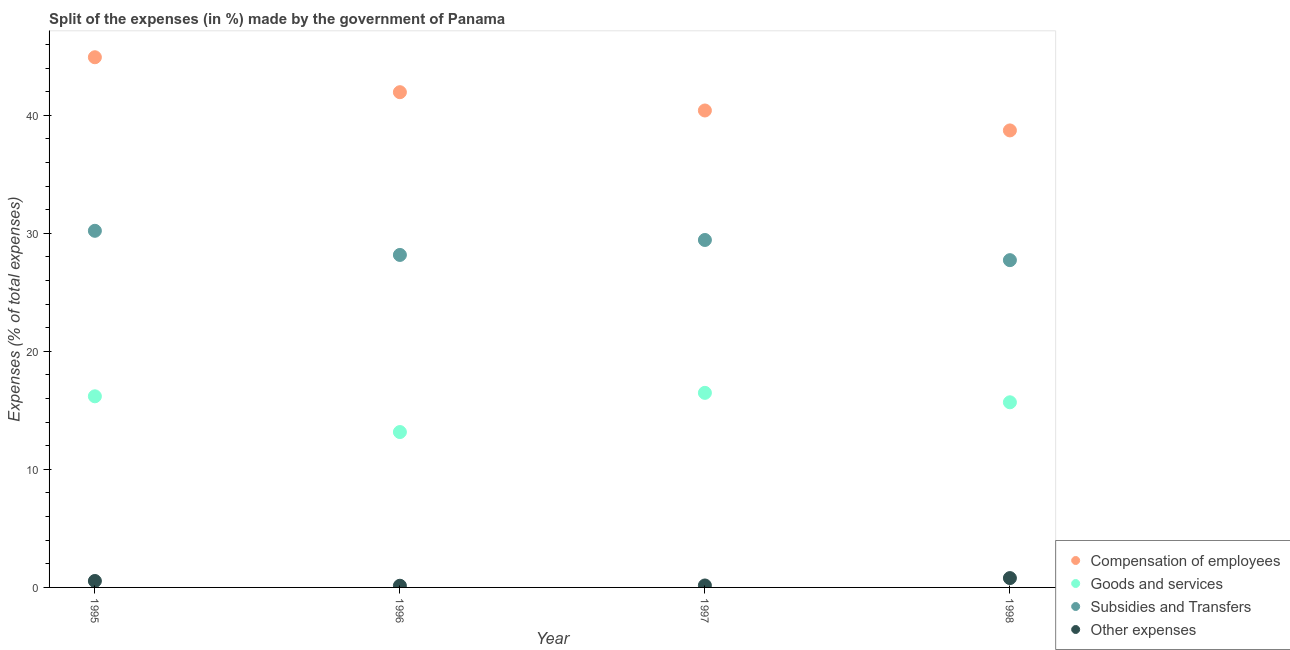Is the number of dotlines equal to the number of legend labels?
Your answer should be compact. Yes. What is the percentage of amount spent on compensation of employees in 1995?
Offer a very short reply. 44.91. Across all years, what is the maximum percentage of amount spent on subsidies?
Your response must be concise. 30.21. Across all years, what is the minimum percentage of amount spent on other expenses?
Provide a succinct answer. 0.14. In which year was the percentage of amount spent on subsidies minimum?
Provide a short and direct response. 1998. What is the total percentage of amount spent on goods and services in the graph?
Your answer should be very brief. 61.52. What is the difference between the percentage of amount spent on subsidies in 1995 and that in 1997?
Your answer should be very brief. 0.78. What is the difference between the percentage of amount spent on other expenses in 1998 and the percentage of amount spent on goods and services in 1996?
Ensure brevity in your answer.  -12.37. What is the average percentage of amount spent on subsidies per year?
Make the answer very short. 28.88. In the year 1996, what is the difference between the percentage of amount spent on other expenses and percentage of amount spent on compensation of employees?
Your response must be concise. -41.81. What is the ratio of the percentage of amount spent on compensation of employees in 1995 to that in 1996?
Your response must be concise. 1.07. What is the difference between the highest and the second highest percentage of amount spent on goods and services?
Ensure brevity in your answer.  0.29. What is the difference between the highest and the lowest percentage of amount spent on other expenses?
Provide a succinct answer. 0.65. Is it the case that in every year, the sum of the percentage of amount spent on other expenses and percentage of amount spent on compensation of employees is greater than the sum of percentage of amount spent on subsidies and percentage of amount spent on goods and services?
Your response must be concise. Yes. Is the percentage of amount spent on other expenses strictly greater than the percentage of amount spent on goods and services over the years?
Provide a succinct answer. No. How many dotlines are there?
Offer a terse response. 4. What is the difference between two consecutive major ticks on the Y-axis?
Give a very brief answer. 10. Does the graph contain grids?
Your answer should be compact. No. Where does the legend appear in the graph?
Offer a terse response. Bottom right. How many legend labels are there?
Offer a very short reply. 4. What is the title of the graph?
Keep it short and to the point. Split of the expenses (in %) made by the government of Panama. What is the label or title of the X-axis?
Offer a terse response. Year. What is the label or title of the Y-axis?
Give a very brief answer. Expenses (% of total expenses). What is the Expenses (% of total expenses) in Compensation of employees in 1995?
Your answer should be very brief. 44.91. What is the Expenses (% of total expenses) of Goods and services in 1995?
Your answer should be compact. 16.19. What is the Expenses (% of total expenses) in Subsidies and Transfers in 1995?
Offer a very short reply. 30.21. What is the Expenses (% of total expenses) of Other expenses in 1995?
Make the answer very short. 0.55. What is the Expenses (% of total expenses) of Compensation of employees in 1996?
Offer a terse response. 41.95. What is the Expenses (% of total expenses) in Goods and services in 1996?
Keep it short and to the point. 13.16. What is the Expenses (% of total expenses) of Subsidies and Transfers in 1996?
Keep it short and to the point. 28.17. What is the Expenses (% of total expenses) of Other expenses in 1996?
Ensure brevity in your answer.  0.14. What is the Expenses (% of total expenses) in Compensation of employees in 1997?
Your answer should be very brief. 40.4. What is the Expenses (% of total expenses) in Goods and services in 1997?
Provide a succinct answer. 16.48. What is the Expenses (% of total expenses) in Subsidies and Transfers in 1997?
Provide a succinct answer. 29.43. What is the Expenses (% of total expenses) in Other expenses in 1997?
Provide a short and direct response. 0.17. What is the Expenses (% of total expenses) of Compensation of employees in 1998?
Provide a short and direct response. 38.71. What is the Expenses (% of total expenses) of Goods and services in 1998?
Keep it short and to the point. 15.68. What is the Expenses (% of total expenses) in Subsidies and Transfers in 1998?
Ensure brevity in your answer.  27.72. What is the Expenses (% of total expenses) of Other expenses in 1998?
Offer a terse response. 0.79. Across all years, what is the maximum Expenses (% of total expenses) of Compensation of employees?
Provide a succinct answer. 44.91. Across all years, what is the maximum Expenses (% of total expenses) in Goods and services?
Make the answer very short. 16.48. Across all years, what is the maximum Expenses (% of total expenses) in Subsidies and Transfers?
Your response must be concise. 30.21. Across all years, what is the maximum Expenses (% of total expenses) in Other expenses?
Keep it short and to the point. 0.79. Across all years, what is the minimum Expenses (% of total expenses) in Compensation of employees?
Your answer should be compact. 38.71. Across all years, what is the minimum Expenses (% of total expenses) in Goods and services?
Keep it short and to the point. 13.16. Across all years, what is the minimum Expenses (% of total expenses) of Subsidies and Transfers?
Give a very brief answer. 27.72. Across all years, what is the minimum Expenses (% of total expenses) of Other expenses?
Your answer should be very brief. 0.14. What is the total Expenses (% of total expenses) in Compensation of employees in the graph?
Make the answer very short. 165.98. What is the total Expenses (% of total expenses) of Goods and services in the graph?
Keep it short and to the point. 61.52. What is the total Expenses (% of total expenses) in Subsidies and Transfers in the graph?
Keep it short and to the point. 115.53. What is the total Expenses (% of total expenses) of Other expenses in the graph?
Give a very brief answer. 1.65. What is the difference between the Expenses (% of total expenses) in Compensation of employees in 1995 and that in 1996?
Ensure brevity in your answer.  2.96. What is the difference between the Expenses (% of total expenses) of Goods and services in 1995 and that in 1996?
Keep it short and to the point. 3.03. What is the difference between the Expenses (% of total expenses) of Subsidies and Transfers in 1995 and that in 1996?
Your response must be concise. 2.04. What is the difference between the Expenses (% of total expenses) of Other expenses in 1995 and that in 1996?
Your answer should be very brief. 0.4. What is the difference between the Expenses (% of total expenses) of Compensation of employees in 1995 and that in 1997?
Ensure brevity in your answer.  4.51. What is the difference between the Expenses (% of total expenses) of Goods and services in 1995 and that in 1997?
Your response must be concise. -0.29. What is the difference between the Expenses (% of total expenses) in Subsidies and Transfers in 1995 and that in 1997?
Give a very brief answer. 0.78. What is the difference between the Expenses (% of total expenses) in Other expenses in 1995 and that in 1997?
Provide a succinct answer. 0.38. What is the difference between the Expenses (% of total expenses) in Compensation of employees in 1995 and that in 1998?
Offer a terse response. 6.2. What is the difference between the Expenses (% of total expenses) in Goods and services in 1995 and that in 1998?
Your answer should be very brief. 0.51. What is the difference between the Expenses (% of total expenses) in Subsidies and Transfers in 1995 and that in 1998?
Offer a terse response. 2.49. What is the difference between the Expenses (% of total expenses) in Other expenses in 1995 and that in 1998?
Ensure brevity in your answer.  -0.25. What is the difference between the Expenses (% of total expenses) in Compensation of employees in 1996 and that in 1997?
Provide a succinct answer. 1.55. What is the difference between the Expenses (% of total expenses) of Goods and services in 1996 and that in 1997?
Keep it short and to the point. -3.32. What is the difference between the Expenses (% of total expenses) in Subsidies and Transfers in 1996 and that in 1997?
Provide a succinct answer. -1.27. What is the difference between the Expenses (% of total expenses) in Other expenses in 1996 and that in 1997?
Your response must be concise. -0.02. What is the difference between the Expenses (% of total expenses) of Compensation of employees in 1996 and that in 1998?
Provide a succinct answer. 3.24. What is the difference between the Expenses (% of total expenses) in Goods and services in 1996 and that in 1998?
Provide a short and direct response. -2.52. What is the difference between the Expenses (% of total expenses) in Subsidies and Transfers in 1996 and that in 1998?
Offer a terse response. 0.44. What is the difference between the Expenses (% of total expenses) of Other expenses in 1996 and that in 1998?
Provide a short and direct response. -0.65. What is the difference between the Expenses (% of total expenses) of Compensation of employees in 1997 and that in 1998?
Offer a terse response. 1.69. What is the difference between the Expenses (% of total expenses) in Goods and services in 1997 and that in 1998?
Your answer should be very brief. 0.8. What is the difference between the Expenses (% of total expenses) of Subsidies and Transfers in 1997 and that in 1998?
Your answer should be compact. 1.71. What is the difference between the Expenses (% of total expenses) of Other expenses in 1997 and that in 1998?
Make the answer very short. -0.63. What is the difference between the Expenses (% of total expenses) in Compensation of employees in 1995 and the Expenses (% of total expenses) in Goods and services in 1996?
Your answer should be very brief. 31.75. What is the difference between the Expenses (% of total expenses) of Compensation of employees in 1995 and the Expenses (% of total expenses) of Subsidies and Transfers in 1996?
Offer a very short reply. 16.75. What is the difference between the Expenses (% of total expenses) in Compensation of employees in 1995 and the Expenses (% of total expenses) in Other expenses in 1996?
Provide a short and direct response. 44.77. What is the difference between the Expenses (% of total expenses) in Goods and services in 1995 and the Expenses (% of total expenses) in Subsidies and Transfers in 1996?
Your response must be concise. -11.98. What is the difference between the Expenses (% of total expenses) in Goods and services in 1995 and the Expenses (% of total expenses) in Other expenses in 1996?
Offer a terse response. 16.05. What is the difference between the Expenses (% of total expenses) in Subsidies and Transfers in 1995 and the Expenses (% of total expenses) in Other expenses in 1996?
Provide a succinct answer. 30.07. What is the difference between the Expenses (% of total expenses) in Compensation of employees in 1995 and the Expenses (% of total expenses) in Goods and services in 1997?
Ensure brevity in your answer.  28.43. What is the difference between the Expenses (% of total expenses) in Compensation of employees in 1995 and the Expenses (% of total expenses) in Subsidies and Transfers in 1997?
Ensure brevity in your answer.  15.48. What is the difference between the Expenses (% of total expenses) of Compensation of employees in 1995 and the Expenses (% of total expenses) of Other expenses in 1997?
Offer a terse response. 44.75. What is the difference between the Expenses (% of total expenses) of Goods and services in 1995 and the Expenses (% of total expenses) of Subsidies and Transfers in 1997?
Your answer should be very brief. -13.24. What is the difference between the Expenses (% of total expenses) of Goods and services in 1995 and the Expenses (% of total expenses) of Other expenses in 1997?
Offer a very short reply. 16.02. What is the difference between the Expenses (% of total expenses) in Subsidies and Transfers in 1995 and the Expenses (% of total expenses) in Other expenses in 1997?
Give a very brief answer. 30.04. What is the difference between the Expenses (% of total expenses) of Compensation of employees in 1995 and the Expenses (% of total expenses) of Goods and services in 1998?
Your response must be concise. 29.23. What is the difference between the Expenses (% of total expenses) in Compensation of employees in 1995 and the Expenses (% of total expenses) in Subsidies and Transfers in 1998?
Your answer should be compact. 17.19. What is the difference between the Expenses (% of total expenses) in Compensation of employees in 1995 and the Expenses (% of total expenses) in Other expenses in 1998?
Make the answer very short. 44.12. What is the difference between the Expenses (% of total expenses) of Goods and services in 1995 and the Expenses (% of total expenses) of Subsidies and Transfers in 1998?
Keep it short and to the point. -11.53. What is the difference between the Expenses (% of total expenses) in Goods and services in 1995 and the Expenses (% of total expenses) in Other expenses in 1998?
Offer a very short reply. 15.4. What is the difference between the Expenses (% of total expenses) of Subsidies and Transfers in 1995 and the Expenses (% of total expenses) of Other expenses in 1998?
Your answer should be very brief. 29.42. What is the difference between the Expenses (% of total expenses) of Compensation of employees in 1996 and the Expenses (% of total expenses) of Goods and services in 1997?
Your answer should be compact. 25.47. What is the difference between the Expenses (% of total expenses) of Compensation of employees in 1996 and the Expenses (% of total expenses) of Subsidies and Transfers in 1997?
Your response must be concise. 12.52. What is the difference between the Expenses (% of total expenses) in Compensation of employees in 1996 and the Expenses (% of total expenses) in Other expenses in 1997?
Offer a very short reply. 41.79. What is the difference between the Expenses (% of total expenses) in Goods and services in 1996 and the Expenses (% of total expenses) in Subsidies and Transfers in 1997?
Your answer should be very brief. -16.27. What is the difference between the Expenses (% of total expenses) in Goods and services in 1996 and the Expenses (% of total expenses) in Other expenses in 1997?
Offer a very short reply. 13. What is the difference between the Expenses (% of total expenses) in Subsidies and Transfers in 1996 and the Expenses (% of total expenses) in Other expenses in 1997?
Offer a terse response. 28. What is the difference between the Expenses (% of total expenses) in Compensation of employees in 1996 and the Expenses (% of total expenses) in Goods and services in 1998?
Your response must be concise. 26.27. What is the difference between the Expenses (% of total expenses) in Compensation of employees in 1996 and the Expenses (% of total expenses) in Subsidies and Transfers in 1998?
Provide a short and direct response. 14.23. What is the difference between the Expenses (% of total expenses) of Compensation of employees in 1996 and the Expenses (% of total expenses) of Other expenses in 1998?
Keep it short and to the point. 41.16. What is the difference between the Expenses (% of total expenses) of Goods and services in 1996 and the Expenses (% of total expenses) of Subsidies and Transfers in 1998?
Make the answer very short. -14.56. What is the difference between the Expenses (% of total expenses) of Goods and services in 1996 and the Expenses (% of total expenses) of Other expenses in 1998?
Make the answer very short. 12.37. What is the difference between the Expenses (% of total expenses) of Subsidies and Transfers in 1996 and the Expenses (% of total expenses) of Other expenses in 1998?
Offer a very short reply. 27.37. What is the difference between the Expenses (% of total expenses) in Compensation of employees in 1997 and the Expenses (% of total expenses) in Goods and services in 1998?
Provide a short and direct response. 24.72. What is the difference between the Expenses (% of total expenses) of Compensation of employees in 1997 and the Expenses (% of total expenses) of Subsidies and Transfers in 1998?
Your response must be concise. 12.68. What is the difference between the Expenses (% of total expenses) in Compensation of employees in 1997 and the Expenses (% of total expenses) in Other expenses in 1998?
Give a very brief answer. 39.61. What is the difference between the Expenses (% of total expenses) in Goods and services in 1997 and the Expenses (% of total expenses) in Subsidies and Transfers in 1998?
Ensure brevity in your answer.  -11.24. What is the difference between the Expenses (% of total expenses) of Goods and services in 1997 and the Expenses (% of total expenses) of Other expenses in 1998?
Provide a short and direct response. 15.69. What is the difference between the Expenses (% of total expenses) of Subsidies and Transfers in 1997 and the Expenses (% of total expenses) of Other expenses in 1998?
Your response must be concise. 28.64. What is the average Expenses (% of total expenses) of Compensation of employees per year?
Provide a short and direct response. 41.5. What is the average Expenses (% of total expenses) of Goods and services per year?
Give a very brief answer. 15.38. What is the average Expenses (% of total expenses) in Subsidies and Transfers per year?
Offer a very short reply. 28.88. What is the average Expenses (% of total expenses) of Other expenses per year?
Your answer should be very brief. 0.41. In the year 1995, what is the difference between the Expenses (% of total expenses) of Compensation of employees and Expenses (% of total expenses) of Goods and services?
Your answer should be very brief. 28.72. In the year 1995, what is the difference between the Expenses (% of total expenses) of Compensation of employees and Expenses (% of total expenses) of Subsidies and Transfers?
Your answer should be very brief. 14.7. In the year 1995, what is the difference between the Expenses (% of total expenses) of Compensation of employees and Expenses (% of total expenses) of Other expenses?
Ensure brevity in your answer.  44.37. In the year 1995, what is the difference between the Expenses (% of total expenses) in Goods and services and Expenses (% of total expenses) in Subsidies and Transfers?
Ensure brevity in your answer.  -14.02. In the year 1995, what is the difference between the Expenses (% of total expenses) of Goods and services and Expenses (% of total expenses) of Other expenses?
Make the answer very short. 15.64. In the year 1995, what is the difference between the Expenses (% of total expenses) of Subsidies and Transfers and Expenses (% of total expenses) of Other expenses?
Make the answer very short. 29.66. In the year 1996, what is the difference between the Expenses (% of total expenses) in Compensation of employees and Expenses (% of total expenses) in Goods and services?
Keep it short and to the point. 28.79. In the year 1996, what is the difference between the Expenses (% of total expenses) in Compensation of employees and Expenses (% of total expenses) in Subsidies and Transfers?
Give a very brief answer. 13.79. In the year 1996, what is the difference between the Expenses (% of total expenses) of Compensation of employees and Expenses (% of total expenses) of Other expenses?
Your answer should be very brief. 41.81. In the year 1996, what is the difference between the Expenses (% of total expenses) of Goods and services and Expenses (% of total expenses) of Subsidies and Transfers?
Provide a short and direct response. -15. In the year 1996, what is the difference between the Expenses (% of total expenses) in Goods and services and Expenses (% of total expenses) in Other expenses?
Your answer should be very brief. 13.02. In the year 1996, what is the difference between the Expenses (% of total expenses) of Subsidies and Transfers and Expenses (% of total expenses) of Other expenses?
Your answer should be very brief. 28.02. In the year 1997, what is the difference between the Expenses (% of total expenses) of Compensation of employees and Expenses (% of total expenses) of Goods and services?
Provide a succinct answer. 23.92. In the year 1997, what is the difference between the Expenses (% of total expenses) in Compensation of employees and Expenses (% of total expenses) in Subsidies and Transfers?
Provide a succinct answer. 10.97. In the year 1997, what is the difference between the Expenses (% of total expenses) of Compensation of employees and Expenses (% of total expenses) of Other expenses?
Keep it short and to the point. 40.24. In the year 1997, what is the difference between the Expenses (% of total expenses) in Goods and services and Expenses (% of total expenses) in Subsidies and Transfers?
Offer a terse response. -12.95. In the year 1997, what is the difference between the Expenses (% of total expenses) of Goods and services and Expenses (% of total expenses) of Other expenses?
Your answer should be compact. 16.32. In the year 1997, what is the difference between the Expenses (% of total expenses) of Subsidies and Transfers and Expenses (% of total expenses) of Other expenses?
Offer a terse response. 29.27. In the year 1998, what is the difference between the Expenses (% of total expenses) of Compensation of employees and Expenses (% of total expenses) of Goods and services?
Your answer should be compact. 23.03. In the year 1998, what is the difference between the Expenses (% of total expenses) of Compensation of employees and Expenses (% of total expenses) of Subsidies and Transfers?
Offer a very short reply. 10.99. In the year 1998, what is the difference between the Expenses (% of total expenses) of Compensation of employees and Expenses (% of total expenses) of Other expenses?
Your response must be concise. 37.92. In the year 1998, what is the difference between the Expenses (% of total expenses) in Goods and services and Expenses (% of total expenses) in Subsidies and Transfers?
Give a very brief answer. -12.04. In the year 1998, what is the difference between the Expenses (% of total expenses) in Goods and services and Expenses (% of total expenses) in Other expenses?
Your answer should be very brief. 14.89. In the year 1998, what is the difference between the Expenses (% of total expenses) in Subsidies and Transfers and Expenses (% of total expenses) in Other expenses?
Keep it short and to the point. 26.93. What is the ratio of the Expenses (% of total expenses) in Compensation of employees in 1995 to that in 1996?
Offer a very short reply. 1.07. What is the ratio of the Expenses (% of total expenses) in Goods and services in 1995 to that in 1996?
Your answer should be compact. 1.23. What is the ratio of the Expenses (% of total expenses) in Subsidies and Transfers in 1995 to that in 1996?
Your response must be concise. 1.07. What is the ratio of the Expenses (% of total expenses) of Other expenses in 1995 to that in 1996?
Your response must be concise. 3.84. What is the ratio of the Expenses (% of total expenses) of Compensation of employees in 1995 to that in 1997?
Provide a short and direct response. 1.11. What is the ratio of the Expenses (% of total expenses) in Goods and services in 1995 to that in 1997?
Ensure brevity in your answer.  0.98. What is the ratio of the Expenses (% of total expenses) in Subsidies and Transfers in 1995 to that in 1997?
Your answer should be very brief. 1.03. What is the ratio of the Expenses (% of total expenses) in Other expenses in 1995 to that in 1997?
Keep it short and to the point. 3.29. What is the ratio of the Expenses (% of total expenses) of Compensation of employees in 1995 to that in 1998?
Your response must be concise. 1.16. What is the ratio of the Expenses (% of total expenses) in Goods and services in 1995 to that in 1998?
Offer a terse response. 1.03. What is the ratio of the Expenses (% of total expenses) of Subsidies and Transfers in 1995 to that in 1998?
Keep it short and to the point. 1.09. What is the ratio of the Expenses (% of total expenses) of Other expenses in 1995 to that in 1998?
Your response must be concise. 0.69. What is the ratio of the Expenses (% of total expenses) of Compensation of employees in 1996 to that in 1997?
Provide a succinct answer. 1.04. What is the ratio of the Expenses (% of total expenses) in Goods and services in 1996 to that in 1997?
Give a very brief answer. 0.8. What is the ratio of the Expenses (% of total expenses) of Other expenses in 1996 to that in 1997?
Make the answer very short. 0.86. What is the ratio of the Expenses (% of total expenses) in Compensation of employees in 1996 to that in 1998?
Provide a short and direct response. 1.08. What is the ratio of the Expenses (% of total expenses) in Goods and services in 1996 to that in 1998?
Keep it short and to the point. 0.84. What is the ratio of the Expenses (% of total expenses) of Subsidies and Transfers in 1996 to that in 1998?
Make the answer very short. 1.02. What is the ratio of the Expenses (% of total expenses) of Other expenses in 1996 to that in 1998?
Keep it short and to the point. 0.18. What is the ratio of the Expenses (% of total expenses) of Compensation of employees in 1997 to that in 1998?
Provide a short and direct response. 1.04. What is the ratio of the Expenses (% of total expenses) in Goods and services in 1997 to that in 1998?
Give a very brief answer. 1.05. What is the ratio of the Expenses (% of total expenses) of Subsidies and Transfers in 1997 to that in 1998?
Keep it short and to the point. 1.06. What is the ratio of the Expenses (% of total expenses) of Other expenses in 1997 to that in 1998?
Your answer should be compact. 0.21. What is the difference between the highest and the second highest Expenses (% of total expenses) of Compensation of employees?
Keep it short and to the point. 2.96. What is the difference between the highest and the second highest Expenses (% of total expenses) in Goods and services?
Offer a very short reply. 0.29. What is the difference between the highest and the second highest Expenses (% of total expenses) of Subsidies and Transfers?
Offer a very short reply. 0.78. What is the difference between the highest and the second highest Expenses (% of total expenses) of Other expenses?
Offer a terse response. 0.25. What is the difference between the highest and the lowest Expenses (% of total expenses) of Compensation of employees?
Provide a short and direct response. 6.2. What is the difference between the highest and the lowest Expenses (% of total expenses) in Goods and services?
Provide a short and direct response. 3.32. What is the difference between the highest and the lowest Expenses (% of total expenses) in Subsidies and Transfers?
Provide a short and direct response. 2.49. What is the difference between the highest and the lowest Expenses (% of total expenses) in Other expenses?
Provide a succinct answer. 0.65. 